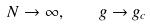<formula> <loc_0><loc_0><loc_500><loc_500>N \to \infty , \quad g \to g _ { c }</formula> 